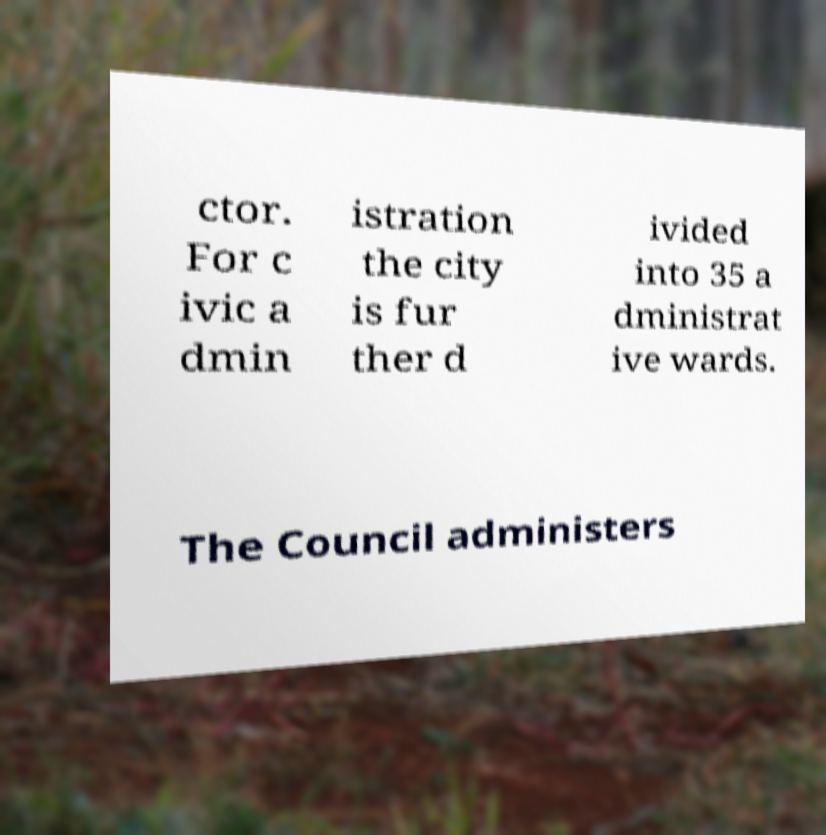Please read and relay the text visible in this image. What does it say? ctor. For c ivic a dmin istration the city is fur ther d ivided into 35 a dministrat ive wards. The Council administers 